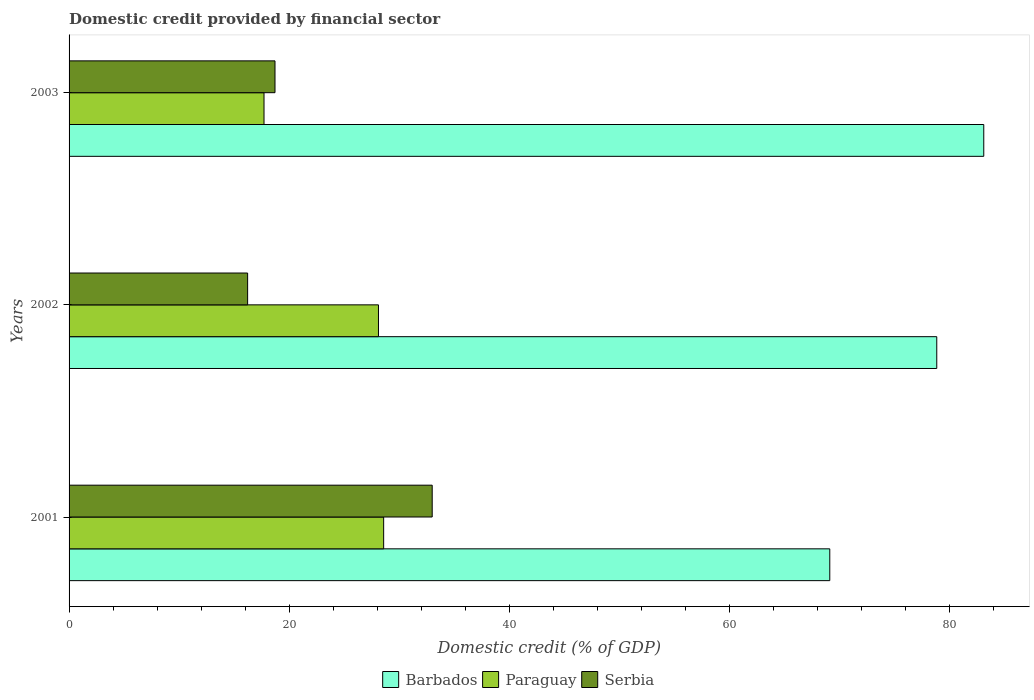Are the number of bars per tick equal to the number of legend labels?
Give a very brief answer. Yes. Are the number of bars on each tick of the Y-axis equal?
Your response must be concise. Yes. How many bars are there on the 1st tick from the bottom?
Provide a short and direct response. 3. What is the label of the 1st group of bars from the top?
Give a very brief answer. 2003. In how many cases, is the number of bars for a given year not equal to the number of legend labels?
Your answer should be very brief. 0. What is the domestic credit in Paraguay in 2003?
Your answer should be very brief. 17.72. Across all years, what is the maximum domestic credit in Barbados?
Your response must be concise. 83.14. Across all years, what is the minimum domestic credit in Barbados?
Provide a short and direct response. 69.15. In which year was the domestic credit in Paraguay maximum?
Give a very brief answer. 2001. In which year was the domestic credit in Paraguay minimum?
Keep it short and to the point. 2003. What is the total domestic credit in Serbia in the graph?
Give a very brief answer. 67.96. What is the difference between the domestic credit in Barbados in 2002 and that in 2003?
Your response must be concise. -4.27. What is the difference between the domestic credit in Paraguay in 2001 and the domestic credit in Serbia in 2002?
Provide a short and direct response. 12.36. What is the average domestic credit in Paraguay per year?
Your response must be concise. 24.81. In the year 2003, what is the difference between the domestic credit in Serbia and domestic credit in Barbados?
Offer a very short reply. -64.42. What is the ratio of the domestic credit in Barbados in 2001 to that in 2002?
Offer a very short reply. 0.88. Is the domestic credit in Paraguay in 2001 less than that in 2002?
Keep it short and to the point. No. Is the difference between the domestic credit in Serbia in 2001 and 2003 greater than the difference between the domestic credit in Barbados in 2001 and 2003?
Your answer should be very brief. Yes. What is the difference between the highest and the second highest domestic credit in Paraguay?
Keep it short and to the point. 0.47. What is the difference between the highest and the lowest domestic credit in Barbados?
Make the answer very short. 14. In how many years, is the domestic credit in Serbia greater than the average domestic credit in Serbia taken over all years?
Provide a short and direct response. 1. Is the sum of the domestic credit in Paraguay in 2001 and 2002 greater than the maximum domestic credit in Serbia across all years?
Ensure brevity in your answer.  Yes. What does the 2nd bar from the top in 2003 represents?
Keep it short and to the point. Paraguay. What does the 1st bar from the bottom in 2003 represents?
Give a very brief answer. Barbados. How many bars are there?
Ensure brevity in your answer.  9. How many years are there in the graph?
Offer a terse response. 3. Are the values on the major ticks of X-axis written in scientific E-notation?
Your answer should be compact. No. Does the graph contain any zero values?
Your answer should be very brief. No. How many legend labels are there?
Provide a succinct answer. 3. How are the legend labels stacked?
Give a very brief answer. Horizontal. What is the title of the graph?
Your answer should be very brief. Domestic credit provided by financial sector. Does "Malawi" appear as one of the legend labels in the graph?
Keep it short and to the point. No. What is the label or title of the X-axis?
Your response must be concise. Domestic credit (% of GDP). What is the label or title of the Y-axis?
Your answer should be very brief. Years. What is the Domestic credit (% of GDP) in Barbados in 2001?
Your response must be concise. 69.15. What is the Domestic credit (% of GDP) in Paraguay in 2001?
Your response must be concise. 28.6. What is the Domestic credit (% of GDP) in Serbia in 2001?
Your answer should be very brief. 33.01. What is the Domestic credit (% of GDP) in Barbados in 2002?
Ensure brevity in your answer.  78.87. What is the Domestic credit (% of GDP) of Paraguay in 2002?
Offer a terse response. 28.12. What is the Domestic credit (% of GDP) in Serbia in 2002?
Provide a succinct answer. 16.23. What is the Domestic credit (% of GDP) of Barbados in 2003?
Provide a short and direct response. 83.14. What is the Domestic credit (% of GDP) of Paraguay in 2003?
Give a very brief answer. 17.72. What is the Domestic credit (% of GDP) in Serbia in 2003?
Keep it short and to the point. 18.72. Across all years, what is the maximum Domestic credit (% of GDP) of Barbados?
Keep it short and to the point. 83.14. Across all years, what is the maximum Domestic credit (% of GDP) of Paraguay?
Your answer should be compact. 28.6. Across all years, what is the maximum Domestic credit (% of GDP) in Serbia?
Your answer should be compact. 33.01. Across all years, what is the minimum Domestic credit (% of GDP) in Barbados?
Make the answer very short. 69.15. Across all years, what is the minimum Domestic credit (% of GDP) of Paraguay?
Give a very brief answer. 17.72. Across all years, what is the minimum Domestic credit (% of GDP) of Serbia?
Your answer should be very brief. 16.23. What is the total Domestic credit (% of GDP) of Barbados in the graph?
Ensure brevity in your answer.  231.16. What is the total Domestic credit (% of GDP) of Paraguay in the graph?
Provide a succinct answer. 74.44. What is the total Domestic credit (% of GDP) in Serbia in the graph?
Provide a short and direct response. 67.96. What is the difference between the Domestic credit (% of GDP) in Barbados in 2001 and that in 2002?
Your response must be concise. -9.72. What is the difference between the Domestic credit (% of GDP) of Paraguay in 2001 and that in 2002?
Offer a terse response. 0.47. What is the difference between the Domestic credit (% of GDP) of Serbia in 2001 and that in 2002?
Your answer should be very brief. 16.78. What is the difference between the Domestic credit (% of GDP) in Barbados in 2001 and that in 2003?
Ensure brevity in your answer.  -14. What is the difference between the Domestic credit (% of GDP) in Paraguay in 2001 and that in 2003?
Provide a short and direct response. 10.87. What is the difference between the Domestic credit (% of GDP) in Serbia in 2001 and that in 2003?
Your answer should be very brief. 14.29. What is the difference between the Domestic credit (% of GDP) of Barbados in 2002 and that in 2003?
Provide a short and direct response. -4.27. What is the difference between the Domestic credit (% of GDP) of Paraguay in 2002 and that in 2003?
Offer a very short reply. 10.4. What is the difference between the Domestic credit (% of GDP) in Serbia in 2002 and that in 2003?
Offer a terse response. -2.49. What is the difference between the Domestic credit (% of GDP) of Barbados in 2001 and the Domestic credit (% of GDP) of Paraguay in 2002?
Your response must be concise. 41.02. What is the difference between the Domestic credit (% of GDP) in Barbados in 2001 and the Domestic credit (% of GDP) in Serbia in 2002?
Provide a short and direct response. 52.92. What is the difference between the Domestic credit (% of GDP) of Paraguay in 2001 and the Domestic credit (% of GDP) of Serbia in 2002?
Offer a terse response. 12.36. What is the difference between the Domestic credit (% of GDP) of Barbados in 2001 and the Domestic credit (% of GDP) of Paraguay in 2003?
Provide a short and direct response. 51.43. What is the difference between the Domestic credit (% of GDP) of Barbados in 2001 and the Domestic credit (% of GDP) of Serbia in 2003?
Give a very brief answer. 50.43. What is the difference between the Domestic credit (% of GDP) of Paraguay in 2001 and the Domestic credit (% of GDP) of Serbia in 2003?
Keep it short and to the point. 9.88. What is the difference between the Domestic credit (% of GDP) of Barbados in 2002 and the Domestic credit (% of GDP) of Paraguay in 2003?
Offer a very short reply. 61.15. What is the difference between the Domestic credit (% of GDP) in Barbados in 2002 and the Domestic credit (% of GDP) in Serbia in 2003?
Give a very brief answer. 60.15. What is the difference between the Domestic credit (% of GDP) in Paraguay in 2002 and the Domestic credit (% of GDP) in Serbia in 2003?
Provide a short and direct response. 9.41. What is the average Domestic credit (% of GDP) of Barbados per year?
Make the answer very short. 77.05. What is the average Domestic credit (% of GDP) of Paraguay per year?
Make the answer very short. 24.81. What is the average Domestic credit (% of GDP) in Serbia per year?
Provide a succinct answer. 22.65. In the year 2001, what is the difference between the Domestic credit (% of GDP) in Barbados and Domestic credit (% of GDP) in Paraguay?
Give a very brief answer. 40.55. In the year 2001, what is the difference between the Domestic credit (% of GDP) of Barbados and Domestic credit (% of GDP) of Serbia?
Your response must be concise. 36.14. In the year 2001, what is the difference between the Domestic credit (% of GDP) in Paraguay and Domestic credit (% of GDP) in Serbia?
Your answer should be compact. -4.41. In the year 2002, what is the difference between the Domestic credit (% of GDP) of Barbados and Domestic credit (% of GDP) of Paraguay?
Your response must be concise. 50.75. In the year 2002, what is the difference between the Domestic credit (% of GDP) of Barbados and Domestic credit (% of GDP) of Serbia?
Ensure brevity in your answer.  62.64. In the year 2002, what is the difference between the Domestic credit (% of GDP) in Paraguay and Domestic credit (% of GDP) in Serbia?
Offer a terse response. 11.89. In the year 2003, what is the difference between the Domestic credit (% of GDP) of Barbados and Domestic credit (% of GDP) of Paraguay?
Provide a short and direct response. 65.42. In the year 2003, what is the difference between the Domestic credit (% of GDP) of Barbados and Domestic credit (% of GDP) of Serbia?
Make the answer very short. 64.42. In the year 2003, what is the difference between the Domestic credit (% of GDP) of Paraguay and Domestic credit (% of GDP) of Serbia?
Provide a short and direct response. -1. What is the ratio of the Domestic credit (% of GDP) in Barbados in 2001 to that in 2002?
Offer a very short reply. 0.88. What is the ratio of the Domestic credit (% of GDP) of Paraguay in 2001 to that in 2002?
Give a very brief answer. 1.02. What is the ratio of the Domestic credit (% of GDP) of Serbia in 2001 to that in 2002?
Offer a very short reply. 2.03. What is the ratio of the Domestic credit (% of GDP) in Barbados in 2001 to that in 2003?
Your answer should be compact. 0.83. What is the ratio of the Domestic credit (% of GDP) in Paraguay in 2001 to that in 2003?
Keep it short and to the point. 1.61. What is the ratio of the Domestic credit (% of GDP) in Serbia in 2001 to that in 2003?
Ensure brevity in your answer.  1.76. What is the ratio of the Domestic credit (% of GDP) of Barbados in 2002 to that in 2003?
Your answer should be compact. 0.95. What is the ratio of the Domestic credit (% of GDP) of Paraguay in 2002 to that in 2003?
Give a very brief answer. 1.59. What is the ratio of the Domestic credit (% of GDP) in Serbia in 2002 to that in 2003?
Keep it short and to the point. 0.87. What is the difference between the highest and the second highest Domestic credit (% of GDP) of Barbados?
Ensure brevity in your answer.  4.27. What is the difference between the highest and the second highest Domestic credit (% of GDP) in Paraguay?
Keep it short and to the point. 0.47. What is the difference between the highest and the second highest Domestic credit (% of GDP) of Serbia?
Provide a short and direct response. 14.29. What is the difference between the highest and the lowest Domestic credit (% of GDP) in Barbados?
Offer a terse response. 14. What is the difference between the highest and the lowest Domestic credit (% of GDP) in Paraguay?
Provide a short and direct response. 10.87. What is the difference between the highest and the lowest Domestic credit (% of GDP) in Serbia?
Offer a very short reply. 16.78. 